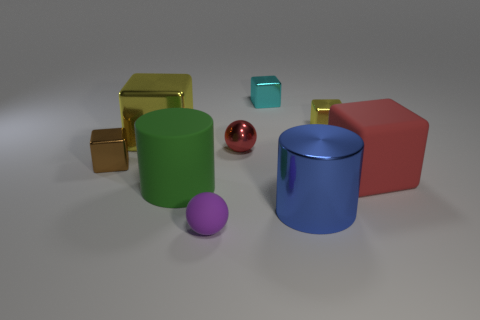Subtract 1 cubes. How many cubes are left? 4 Subtract all blue blocks. Subtract all yellow cylinders. How many blocks are left? 5 Subtract all cylinders. How many objects are left? 7 Add 2 small blue matte things. How many small blue matte things exist? 2 Subtract 0 blue balls. How many objects are left? 9 Subtract all brown cubes. Subtract all blue shiny cylinders. How many objects are left? 7 Add 2 metal cubes. How many metal cubes are left? 6 